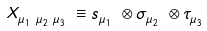<formula> <loc_0><loc_0><loc_500><loc_500>X ^ { \ } _ { \mu ^ { \ } _ { 1 } \mu ^ { \ } _ { 2 } \mu ^ { \ } _ { 3 } } \equiv s ^ { \ } _ { \mu ^ { \ } _ { 1 } } \otimes \sigma ^ { \ } _ { \mu ^ { \ } _ { 2 } } \otimes \tau ^ { \ } _ { \mu ^ { \ } _ { 3 } }</formula> 